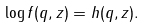<formula> <loc_0><loc_0><loc_500><loc_500>\log f ( q , z ) = h ( q , z ) .</formula> 